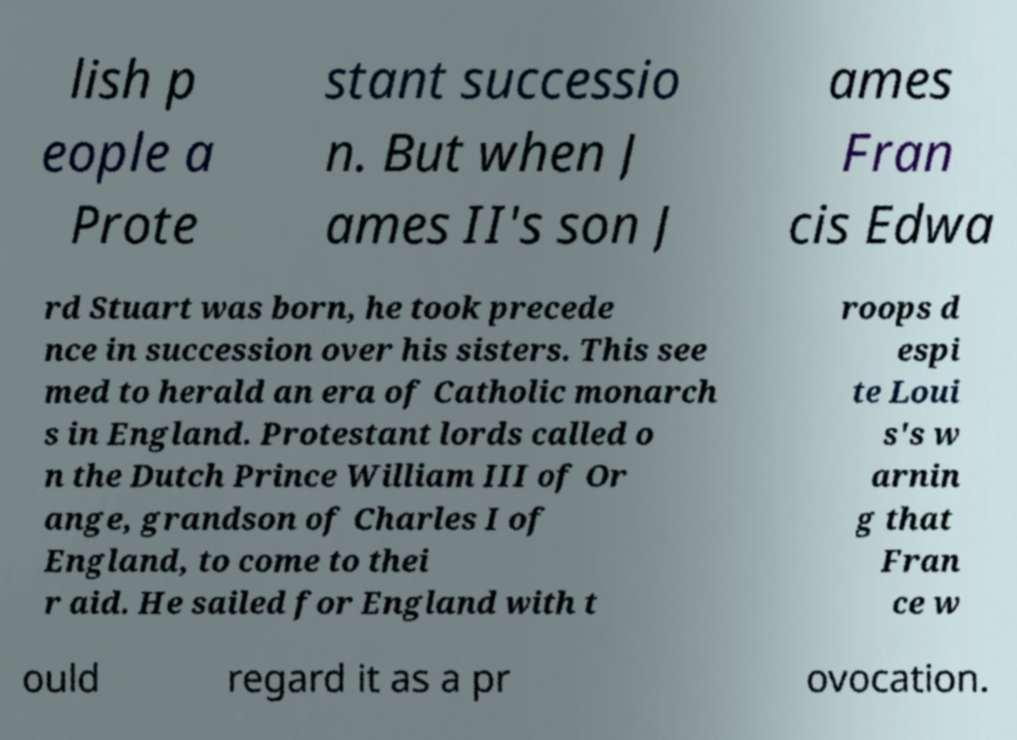There's text embedded in this image that I need extracted. Can you transcribe it verbatim? lish p eople a Prote stant successio n. But when J ames II's son J ames Fran cis Edwa rd Stuart was born, he took precede nce in succession over his sisters. This see med to herald an era of Catholic monarch s in England. Protestant lords called o n the Dutch Prince William III of Or ange, grandson of Charles I of England, to come to thei r aid. He sailed for England with t roops d espi te Loui s's w arnin g that Fran ce w ould regard it as a pr ovocation. 